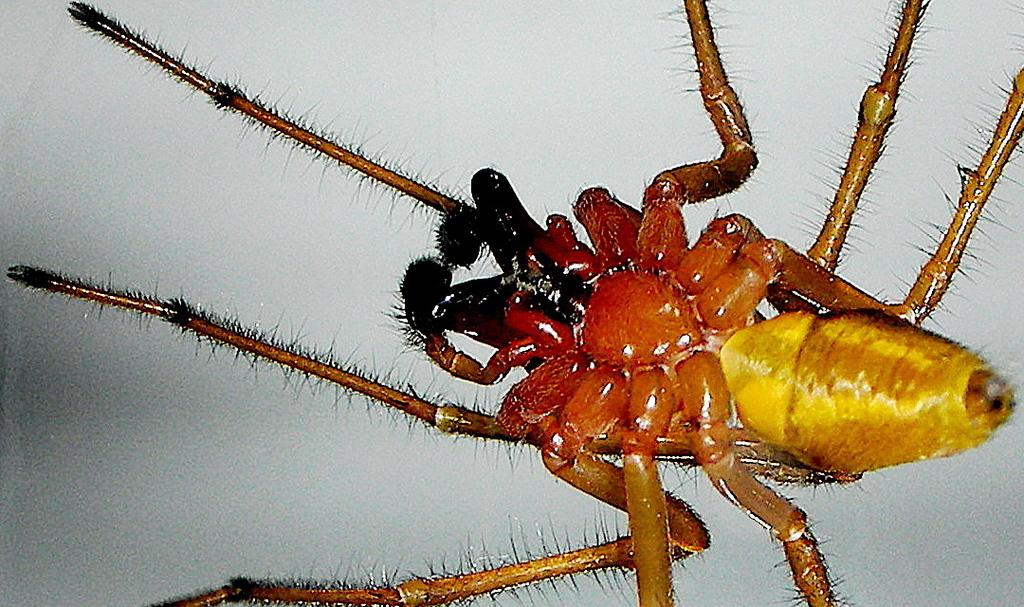What type of creature can be seen in the image? There is an insect in the image. What is the color of the surface where the insect is located? The insect is on a white surface. What type of plate is the insect rubbing against in the image? There is no plate present in the image, and the insect is not rubbing against anything. 